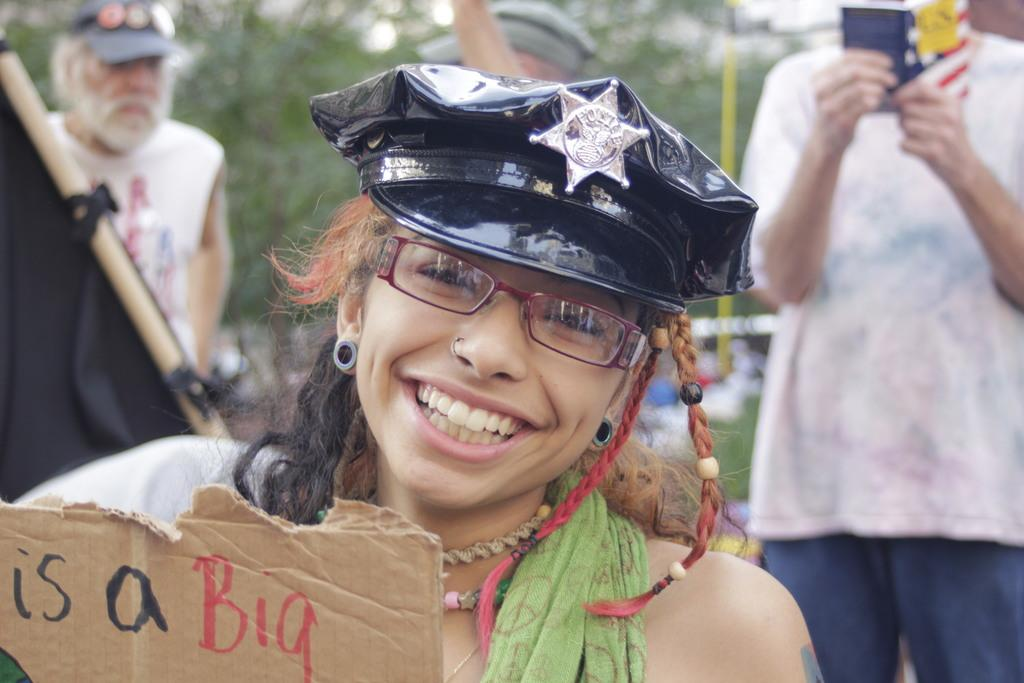What is the woman doing in the image? The woman is folding a cardboard sheet in the image. What is the person on the left side of the image holding? There is a person holding a book in the image. What is the person on the right side of the image holding? There is a person holding a stick in the image. What type of pie is the goat eating in the image? There is no goat or pie present in the image. What advice does the mom give to the woman in the image? There is no mom present in the image, and therefore no advice can be given. 